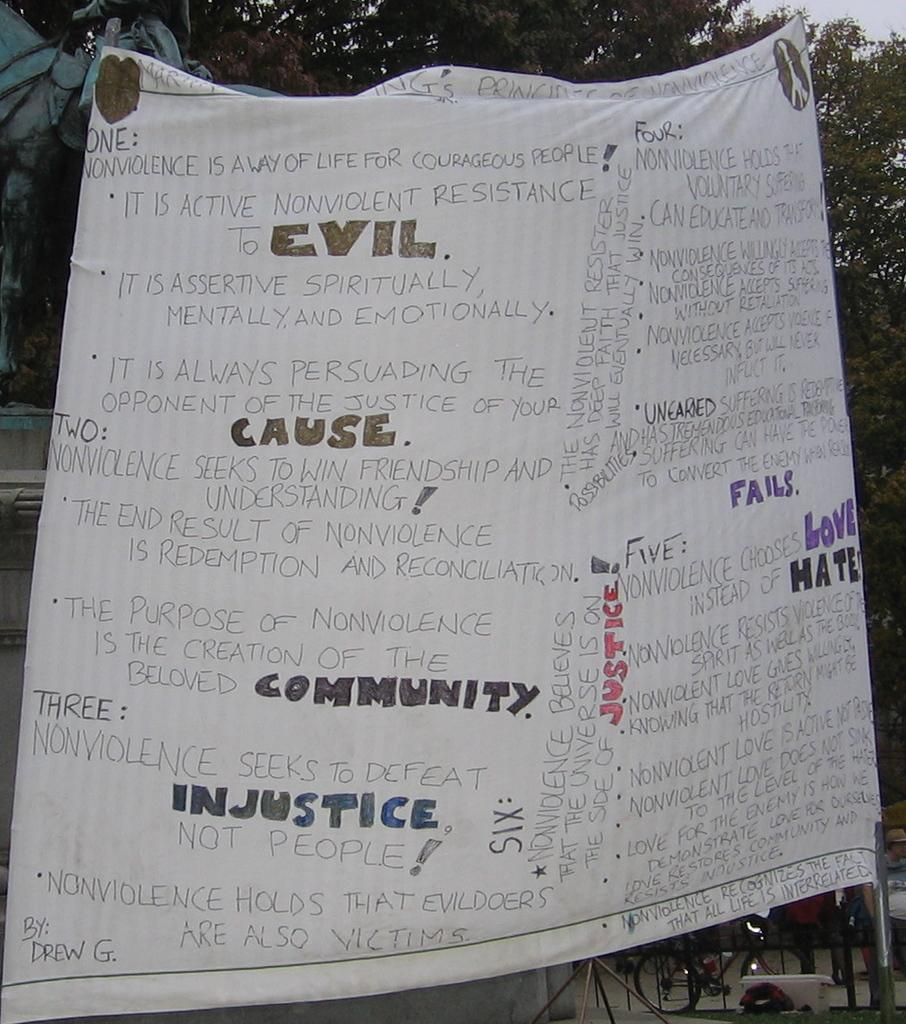What is located at the front of the image? There is a banner in the front of the image. What can be found on the banner? Something is written on the banner. What type of natural elements can be seen in the background of the image? There are trees and sky visible in the background of the image. What mode of transportation is present in the background of the image? There is a bicycle in the background of the image. What else can be seen in the background of the image? There are objects in the background of the image. Can you tell me how many carpenters are working on the yak in the image? There are no carpenters or yaks present in the image. 